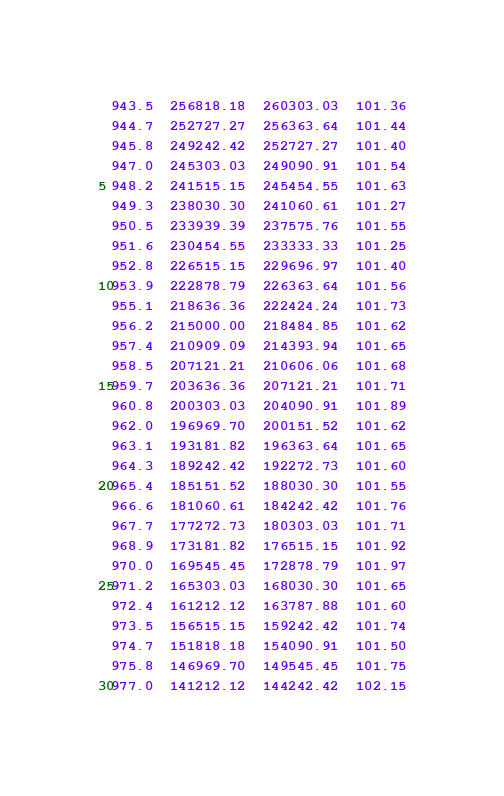<code> <loc_0><loc_0><loc_500><loc_500><_SML_>943.5  256818.18  260303.03  101.36
944.7  252727.27  256363.64  101.44
945.8  249242.42  252727.27  101.40
947.0  245303.03  249090.91  101.54
948.2  241515.15  245454.55  101.63
949.3  238030.30  241060.61  101.27
950.5  233939.39  237575.76  101.55
951.6  230454.55  233333.33  101.25
952.8  226515.15  229696.97  101.40
953.9  222878.79  226363.64  101.56
955.1  218636.36  222424.24  101.73
956.2  215000.00  218484.85  101.62
957.4  210909.09  214393.94  101.65
958.5  207121.21  210606.06  101.68
959.7  203636.36  207121.21  101.71
960.8  200303.03  204090.91  101.89
962.0  196969.70  200151.52  101.62
963.1  193181.82  196363.64  101.65
964.3  189242.42  192272.73  101.60
965.4  185151.52  188030.30  101.55
966.6  181060.61  184242.42  101.76
967.7  177272.73  180303.03  101.71
968.9  173181.82  176515.15  101.92
970.0  169545.45  172878.79  101.97
971.2  165303.03  168030.30  101.65
972.4  161212.12  163787.88  101.60
973.5  156515.15  159242.42  101.74
974.7  151818.18  154090.91  101.50
975.8  146969.70  149545.45  101.75
977.0  141212.12  144242.42  102.15</code> 